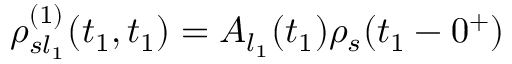<formula> <loc_0><loc_0><loc_500><loc_500>\rho _ { s l _ { 1 } } ^ { ( 1 ) } ( t _ { 1 } , t _ { 1 } ) = A _ { l _ { 1 } } ( t _ { 1 } ) \rho _ { s } ( t _ { 1 } - 0 ^ { + } )</formula> 